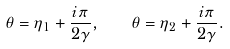Convert formula to latex. <formula><loc_0><loc_0><loc_500><loc_500>\theta = \eta _ { 1 } + \frac { i \pi } { 2 \gamma } , \quad \theta = \eta _ { 2 } + \frac { i \pi } { 2 \gamma } .</formula> 